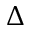Convert formula to latex. <formula><loc_0><loc_0><loc_500><loc_500>\Delta</formula> 